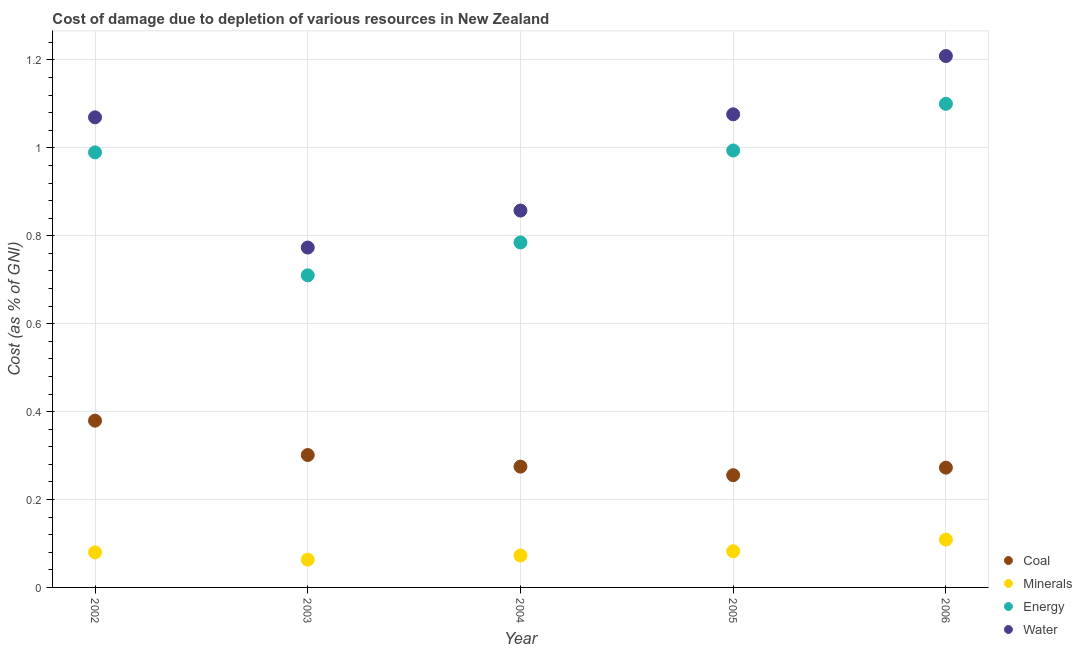How many different coloured dotlines are there?
Offer a very short reply. 4. What is the cost of damage due to depletion of energy in 2002?
Provide a succinct answer. 0.99. Across all years, what is the maximum cost of damage due to depletion of minerals?
Make the answer very short. 0.11. Across all years, what is the minimum cost of damage due to depletion of water?
Your answer should be compact. 0.77. In which year was the cost of damage due to depletion of coal maximum?
Ensure brevity in your answer.  2002. What is the total cost of damage due to depletion of minerals in the graph?
Make the answer very short. 0.41. What is the difference between the cost of damage due to depletion of minerals in 2002 and that in 2006?
Offer a very short reply. -0.03. What is the difference between the cost of damage due to depletion of energy in 2002 and the cost of damage due to depletion of coal in 2004?
Your answer should be very brief. 0.71. What is the average cost of damage due to depletion of coal per year?
Offer a terse response. 0.3. In the year 2003, what is the difference between the cost of damage due to depletion of water and cost of damage due to depletion of minerals?
Provide a short and direct response. 0.71. What is the ratio of the cost of damage due to depletion of water in 2003 to that in 2004?
Provide a succinct answer. 0.9. Is the difference between the cost of damage due to depletion of water in 2003 and 2006 greater than the difference between the cost of damage due to depletion of energy in 2003 and 2006?
Give a very brief answer. No. What is the difference between the highest and the second highest cost of damage due to depletion of coal?
Offer a terse response. 0.08. What is the difference between the highest and the lowest cost of damage due to depletion of energy?
Offer a terse response. 0.39. Is the sum of the cost of damage due to depletion of energy in 2005 and 2006 greater than the maximum cost of damage due to depletion of minerals across all years?
Offer a terse response. Yes. Is it the case that in every year, the sum of the cost of damage due to depletion of coal and cost of damage due to depletion of minerals is greater than the cost of damage due to depletion of energy?
Keep it short and to the point. No. Does the cost of damage due to depletion of water monotonically increase over the years?
Offer a very short reply. No. How many dotlines are there?
Provide a succinct answer. 4. How many years are there in the graph?
Make the answer very short. 5. What is the difference between two consecutive major ticks on the Y-axis?
Your response must be concise. 0.2. Are the values on the major ticks of Y-axis written in scientific E-notation?
Offer a very short reply. No. Does the graph contain any zero values?
Ensure brevity in your answer.  No. Does the graph contain grids?
Provide a short and direct response. Yes. What is the title of the graph?
Ensure brevity in your answer.  Cost of damage due to depletion of various resources in New Zealand . Does "Offering training" appear as one of the legend labels in the graph?
Your answer should be compact. No. What is the label or title of the Y-axis?
Your response must be concise. Cost (as % of GNI). What is the Cost (as % of GNI) of Coal in 2002?
Your answer should be compact. 0.38. What is the Cost (as % of GNI) in Minerals in 2002?
Provide a succinct answer. 0.08. What is the Cost (as % of GNI) of Energy in 2002?
Make the answer very short. 0.99. What is the Cost (as % of GNI) of Water in 2002?
Your answer should be compact. 1.07. What is the Cost (as % of GNI) of Coal in 2003?
Provide a succinct answer. 0.3. What is the Cost (as % of GNI) in Minerals in 2003?
Your answer should be compact. 0.06. What is the Cost (as % of GNI) in Energy in 2003?
Provide a succinct answer. 0.71. What is the Cost (as % of GNI) of Water in 2003?
Your response must be concise. 0.77. What is the Cost (as % of GNI) in Coal in 2004?
Keep it short and to the point. 0.27. What is the Cost (as % of GNI) in Minerals in 2004?
Ensure brevity in your answer.  0.07. What is the Cost (as % of GNI) of Energy in 2004?
Offer a terse response. 0.78. What is the Cost (as % of GNI) in Water in 2004?
Provide a short and direct response. 0.86. What is the Cost (as % of GNI) of Coal in 2005?
Your answer should be very brief. 0.26. What is the Cost (as % of GNI) in Minerals in 2005?
Give a very brief answer. 0.08. What is the Cost (as % of GNI) of Energy in 2005?
Keep it short and to the point. 0.99. What is the Cost (as % of GNI) of Water in 2005?
Provide a short and direct response. 1.08. What is the Cost (as % of GNI) of Coal in 2006?
Make the answer very short. 0.27. What is the Cost (as % of GNI) in Minerals in 2006?
Offer a very short reply. 0.11. What is the Cost (as % of GNI) of Energy in 2006?
Keep it short and to the point. 1.1. What is the Cost (as % of GNI) of Water in 2006?
Offer a terse response. 1.21. Across all years, what is the maximum Cost (as % of GNI) in Coal?
Keep it short and to the point. 0.38. Across all years, what is the maximum Cost (as % of GNI) of Minerals?
Your response must be concise. 0.11. Across all years, what is the maximum Cost (as % of GNI) in Energy?
Offer a terse response. 1.1. Across all years, what is the maximum Cost (as % of GNI) in Water?
Offer a very short reply. 1.21. Across all years, what is the minimum Cost (as % of GNI) in Coal?
Your answer should be very brief. 0.26. Across all years, what is the minimum Cost (as % of GNI) of Minerals?
Provide a succinct answer. 0.06. Across all years, what is the minimum Cost (as % of GNI) in Energy?
Offer a very short reply. 0.71. Across all years, what is the minimum Cost (as % of GNI) in Water?
Your answer should be compact. 0.77. What is the total Cost (as % of GNI) of Coal in the graph?
Give a very brief answer. 1.48. What is the total Cost (as % of GNI) in Minerals in the graph?
Give a very brief answer. 0.41. What is the total Cost (as % of GNI) in Energy in the graph?
Provide a succinct answer. 4.58. What is the total Cost (as % of GNI) of Water in the graph?
Ensure brevity in your answer.  4.99. What is the difference between the Cost (as % of GNI) of Coal in 2002 and that in 2003?
Give a very brief answer. 0.08. What is the difference between the Cost (as % of GNI) in Minerals in 2002 and that in 2003?
Make the answer very short. 0.02. What is the difference between the Cost (as % of GNI) of Energy in 2002 and that in 2003?
Offer a terse response. 0.28. What is the difference between the Cost (as % of GNI) in Water in 2002 and that in 2003?
Your answer should be very brief. 0.3. What is the difference between the Cost (as % of GNI) in Coal in 2002 and that in 2004?
Offer a very short reply. 0.1. What is the difference between the Cost (as % of GNI) of Minerals in 2002 and that in 2004?
Offer a terse response. 0.01. What is the difference between the Cost (as % of GNI) in Energy in 2002 and that in 2004?
Offer a very short reply. 0.2. What is the difference between the Cost (as % of GNI) of Water in 2002 and that in 2004?
Your response must be concise. 0.21. What is the difference between the Cost (as % of GNI) of Coal in 2002 and that in 2005?
Your response must be concise. 0.12. What is the difference between the Cost (as % of GNI) of Minerals in 2002 and that in 2005?
Offer a very short reply. -0. What is the difference between the Cost (as % of GNI) in Energy in 2002 and that in 2005?
Offer a very short reply. -0. What is the difference between the Cost (as % of GNI) of Water in 2002 and that in 2005?
Ensure brevity in your answer.  -0.01. What is the difference between the Cost (as % of GNI) in Coal in 2002 and that in 2006?
Your answer should be very brief. 0.11. What is the difference between the Cost (as % of GNI) in Minerals in 2002 and that in 2006?
Ensure brevity in your answer.  -0.03. What is the difference between the Cost (as % of GNI) of Energy in 2002 and that in 2006?
Give a very brief answer. -0.11. What is the difference between the Cost (as % of GNI) in Water in 2002 and that in 2006?
Keep it short and to the point. -0.14. What is the difference between the Cost (as % of GNI) in Coal in 2003 and that in 2004?
Your answer should be compact. 0.03. What is the difference between the Cost (as % of GNI) in Minerals in 2003 and that in 2004?
Provide a succinct answer. -0.01. What is the difference between the Cost (as % of GNI) of Energy in 2003 and that in 2004?
Your response must be concise. -0.07. What is the difference between the Cost (as % of GNI) of Water in 2003 and that in 2004?
Your answer should be very brief. -0.08. What is the difference between the Cost (as % of GNI) in Coal in 2003 and that in 2005?
Offer a very short reply. 0.05. What is the difference between the Cost (as % of GNI) of Minerals in 2003 and that in 2005?
Your answer should be compact. -0.02. What is the difference between the Cost (as % of GNI) in Energy in 2003 and that in 2005?
Keep it short and to the point. -0.28. What is the difference between the Cost (as % of GNI) in Water in 2003 and that in 2005?
Offer a very short reply. -0.3. What is the difference between the Cost (as % of GNI) of Coal in 2003 and that in 2006?
Your answer should be very brief. 0.03. What is the difference between the Cost (as % of GNI) in Minerals in 2003 and that in 2006?
Ensure brevity in your answer.  -0.05. What is the difference between the Cost (as % of GNI) in Energy in 2003 and that in 2006?
Ensure brevity in your answer.  -0.39. What is the difference between the Cost (as % of GNI) of Water in 2003 and that in 2006?
Provide a short and direct response. -0.44. What is the difference between the Cost (as % of GNI) in Coal in 2004 and that in 2005?
Your response must be concise. 0.02. What is the difference between the Cost (as % of GNI) of Minerals in 2004 and that in 2005?
Offer a very short reply. -0.01. What is the difference between the Cost (as % of GNI) of Energy in 2004 and that in 2005?
Make the answer very short. -0.21. What is the difference between the Cost (as % of GNI) in Water in 2004 and that in 2005?
Your answer should be very brief. -0.22. What is the difference between the Cost (as % of GNI) of Coal in 2004 and that in 2006?
Give a very brief answer. 0. What is the difference between the Cost (as % of GNI) of Minerals in 2004 and that in 2006?
Your response must be concise. -0.04. What is the difference between the Cost (as % of GNI) in Energy in 2004 and that in 2006?
Make the answer very short. -0.32. What is the difference between the Cost (as % of GNI) of Water in 2004 and that in 2006?
Keep it short and to the point. -0.35. What is the difference between the Cost (as % of GNI) of Coal in 2005 and that in 2006?
Keep it short and to the point. -0.02. What is the difference between the Cost (as % of GNI) in Minerals in 2005 and that in 2006?
Provide a succinct answer. -0.03. What is the difference between the Cost (as % of GNI) of Energy in 2005 and that in 2006?
Your answer should be very brief. -0.11. What is the difference between the Cost (as % of GNI) in Water in 2005 and that in 2006?
Make the answer very short. -0.13. What is the difference between the Cost (as % of GNI) of Coal in 2002 and the Cost (as % of GNI) of Minerals in 2003?
Your answer should be very brief. 0.32. What is the difference between the Cost (as % of GNI) of Coal in 2002 and the Cost (as % of GNI) of Energy in 2003?
Ensure brevity in your answer.  -0.33. What is the difference between the Cost (as % of GNI) of Coal in 2002 and the Cost (as % of GNI) of Water in 2003?
Your response must be concise. -0.39. What is the difference between the Cost (as % of GNI) in Minerals in 2002 and the Cost (as % of GNI) in Energy in 2003?
Your response must be concise. -0.63. What is the difference between the Cost (as % of GNI) of Minerals in 2002 and the Cost (as % of GNI) of Water in 2003?
Your answer should be compact. -0.69. What is the difference between the Cost (as % of GNI) in Energy in 2002 and the Cost (as % of GNI) in Water in 2003?
Offer a very short reply. 0.22. What is the difference between the Cost (as % of GNI) in Coal in 2002 and the Cost (as % of GNI) in Minerals in 2004?
Keep it short and to the point. 0.31. What is the difference between the Cost (as % of GNI) in Coal in 2002 and the Cost (as % of GNI) in Energy in 2004?
Ensure brevity in your answer.  -0.41. What is the difference between the Cost (as % of GNI) of Coal in 2002 and the Cost (as % of GNI) of Water in 2004?
Offer a terse response. -0.48. What is the difference between the Cost (as % of GNI) of Minerals in 2002 and the Cost (as % of GNI) of Energy in 2004?
Provide a short and direct response. -0.71. What is the difference between the Cost (as % of GNI) of Minerals in 2002 and the Cost (as % of GNI) of Water in 2004?
Keep it short and to the point. -0.78. What is the difference between the Cost (as % of GNI) of Energy in 2002 and the Cost (as % of GNI) of Water in 2004?
Provide a succinct answer. 0.13. What is the difference between the Cost (as % of GNI) of Coal in 2002 and the Cost (as % of GNI) of Minerals in 2005?
Your response must be concise. 0.3. What is the difference between the Cost (as % of GNI) in Coal in 2002 and the Cost (as % of GNI) in Energy in 2005?
Make the answer very short. -0.61. What is the difference between the Cost (as % of GNI) in Coal in 2002 and the Cost (as % of GNI) in Water in 2005?
Give a very brief answer. -0.7. What is the difference between the Cost (as % of GNI) of Minerals in 2002 and the Cost (as % of GNI) of Energy in 2005?
Keep it short and to the point. -0.91. What is the difference between the Cost (as % of GNI) in Minerals in 2002 and the Cost (as % of GNI) in Water in 2005?
Keep it short and to the point. -1. What is the difference between the Cost (as % of GNI) in Energy in 2002 and the Cost (as % of GNI) in Water in 2005?
Offer a terse response. -0.09. What is the difference between the Cost (as % of GNI) in Coal in 2002 and the Cost (as % of GNI) in Minerals in 2006?
Offer a terse response. 0.27. What is the difference between the Cost (as % of GNI) in Coal in 2002 and the Cost (as % of GNI) in Energy in 2006?
Offer a terse response. -0.72. What is the difference between the Cost (as % of GNI) of Coal in 2002 and the Cost (as % of GNI) of Water in 2006?
Keep it short and to the point. -0.83. What is the difference between the Cost (as % of GNI) of Minerals in 2002 and the Cost (as % of GNI) of Energy in 2006?
Provide a short and direct response. -1.02. What is the difference between the Cost (as % of GNI) in Minerals in 2002 and the Cost (as % of GNI) in Water in 2006?
Keep it short and to the point. -1.13. What is the difference between the Cost (as % of GNI) in Energy in 2002 and the Cost (as % of GNI) in Water in 2006?
Provide a succinct answer. -0.22. What is the difference between the Cost (as % of GNI) of Coal in 2003 and the Cost (as % of GNI) of Minerals in 2004?
Provide a short and direct response. 0.23. What is the difference between the Cost (as % of GNI) of Coal in 2003 and the Cost (as % of GNI) of Energy in 2004?
Offer a very short reply. -0.48. What is the difference between the Cost (as % of GNI) of Coal in 2003 and the Cost (as % of GNI) of Water in 2004?
Your answer should be compact. -0.56. What is the difference between the Cost (as % of GNI) of Minerals in 2003 and the Cost (as % of GNI) of Energy in 2004?
Provide a succinct answer. -0.72. What is the difference between the Cost (as % of GNI) of Minerals in 2003 and the Cost (as % of GNI) of Water in 2004?
Provide a succinct answer. -0.79. What is the difference between the Cost (as % of GNI) in Energy in 2003 and the Cost (as % of GNI) in Water in 2004?
Give a very brief answer. -0.15. What is the difference between the Cost (as % of GNI) of Coal in 2003 and the Cost (as % of GNI) of Minerals in 2005?
Make the answer very short. 0.22. What is the difference between the Cost (as % of GNI) of Coal in 2003 and the Cost (as % of GNI) of Energy in 2005?
Your answer should be compact. -0.69. What is the difference between the Cost (as % of GNI) in Coal in 2003 and the Cost (as % of GNI) in Water in 2005?
Keep it short and to the point. -0.78. What is the difference between the Cost (as % of GNI) of Minerals in 2003 and the Cost (as % of GNI) of Energy in 2005?
Your answer should be very brief. -0.93. What is the difference between the Cost (as % of GNI) in Minerals in 2003 and the Cost (as % of GNI) in Water in 2005?
Offer a terse response. -1.01. What is the difference between the Cost (as % of GNI) in Energy in 2003 and the Cost (as % of GNI) in Water in 2005?
Provide a succinct answer. -0.37. What is the difference between the Cost (as % of GNI) of Coal in 2003 and the Cost (as % of GNI) of Minerals in 2006?
Give a very brief answer. 0.19. What is the difference between the Cost (as % of GNI) in Coal in 2003 and the Cost (as % of GNI) in Energy in 2006?
Your answer should be very brief. -0.8. What is the difference between the Cost (as % of GNI) of Coal in 2003 and the Cost (as % of GNI) of Water in 2006?
Keep it short and to the point. -0.91. What is the difference between the Cost (as % of GNI) of Minerals in 2003 and the Cost (as % of GNI) of Energy in 2006?
Your answer should be compact. -1.04. What is the difference between the Cost (as % of GNI) in Minerals in 2003 and the Cost (as % of GNI) in Water in 2006?
Ensure brevity in your answer.  -1.15. What is the difference between the Cost (as % of GNI) in Energy in 2003 and the Cost (as % of GNI) in Water in 2006?
Give a very brief answer. -0.5. What is the difference between the Cost (as % of GNI) in Coal in 2004 and the Cost (as % of GNI) in Minerals in 2005?
Your answer should be compact. 0.19. What is the difference between the Cost (as % of GNI) of Coal in 2004 and the Cost (as % of GNI) of Energy in 2005?
Give a very brief answer. -0.72. What is the difference between the Cost (as % of GNI) of Coal in 2004 and the Cost (as % of GNI) of Water in 2005?
Offer a very short reply. -0.8. What is the difference between the Cost (as % of GNI) of Minerals in 2004 and the Cost (as % of GNI) of Energy in 2005?
Your response must be concise. -0.92. What is the difference between the Cost (as % of GNI) in Minerals in 2004 and the Cost (as % of GNI) in Water in 2005?
Give a very brief answer. -1. What is the difference between the Cost (as % of GNI) of Energy in 2004 and the Cost (as % of GNI) of Water in 2005?
Ensure brevity in your answer.  -0.29. What is the difference between the Cost (as % of GNI) in Coal in 2004 and the Cost (as % of GNI) in Minerals in 2006?
Keep it short and to the point. 0.17. What is the difference between the Cost (as % of GNI) in Coal in 2004 and the Cost (as % of GNI) in Energy in 2006?
Offer a terse response. -0.83. What is the difference between the Cost (as % of GNI) in Coal in 2004 and the Cost (as % of GNI) in Water in 2006?
Offer a very short reply. -0.93. What is the difference between the Cost (as % of GNI) in Minerals in 2004 and the Cost (as % of GNI) in Energy in 2006?
Make the answer very short. -1.03. What is the difference between the Cost (as % of GNI) of Minerals in 2004 and the Cost (as % of GNI) of Water in 2006?
Provide a short and direct response. -1.14. What is the difference between the Cost (as % of GNI) of Energy in 2004 and the Cost (as % of GNI) of Water in 2006?
Keep it short and to the point. -0.42. What is the difference between the Cost (as % of GNI) in Coal in 2005 and the Cost (as % of GNI) in Minerals in 2006?
Your answer should be very brief. 0.15. What is the difference between the Cost (as % of GNI) in Coal in 2005 and the Cost (as % of GNI) in Energy in 2006?
Give a very brief answer. -0.84. What is the difference between the Cost (as % of GNI) in Coal in 2005 and the Cost (as % of GNI) in Water in 2006?
Your response must be concise. -0.95. What is the difference between the Cost (as % of GNI) of Minerals in 2005 and the Cost (as % of GNI) of Energy in 2006?
Provide a succinct answer. -1.02. What is the difference between the Cost (as % of GNI) of Minerals in 2005 and the Cost (as % of GNI) of Water in 2006?
Offer a very short reply. -1.13. What is the difference between the Cost (as % of GNI) in Energy in 2005 and the Cost (as % of GNI) in Water in 2006?
Provide a succinct answer. -0.21. What is the average Cost (as % of GNI) in Coal per year?
Provide a succinct answer. 0.3. What is the average Cost (as % of GNI) in Minerals per year?
Ensure brevity in your answer.  0.08. What is the average Cost (as % of GNI) of Energy per year?
Offer a terse response. 0.92. What is the average Cost (as % of GNI) of Water per year?
Your answer should be very brief. 1. In the year 2002, what is the difference between the Cost (as % of GNI) in Coal and Cost (as % of GNI) in Minerals?
Provide a succinct answer. 0.3. In the year 2002, what is the difference between the Cost (as % of GNI) of Coal and Cost (as % of GNI) of Energy?
Keep it short and to the point. -0.61. In the year 2002, what is the difference between the Cost (as % of GNI) in Coal and Cost (as % of GNI) in Water?
Ensure brevity in your answer.  -0.69. In the year 2002, what is the difference between the Cost (as % of GNI) in Minerals and Cost (as % of GNI) in Energy?
Your answer should be compact. -0.91. In the year 2002, what is the difference between the Cost (as % of GNI) of Minerals and Cost (as % of GNI) of Water?
Your answer should be compact. -0.99. In the year 2002, what is the difference between the Cost (as % of GNI) of Energy and Cost (as % of GNI) of Water?
Provide a short and direct response. -0.08. In the year 2003, what is the difference between the Cost (as % of GNI) in Coal and Cost (as % of GNI) in Minerals?
Give a very brief answer. 0.24. In the year 2003, what is the difference between the Cost (as % of GNI) of Coal and Cost (as % of GNI) of Energy?
Your answer should be very brief. -0.41. In the year 2003, what is the difference between the Cost (as % of GNI) in Coal and Cost (as % of GNI) in Water?
Make the answer very short. -0.47. In the year 2003, what is the difference between the Cost (as % of GNI) in Minerals and Cost (as % of GNI) in Energy?
Offer a very short reply. -0.65. In the year 2003, what is the difference between the Cost (as % of GNI) of Minerals and Cost (as % of GNI) of Water?
Make the answer very short. -0.71. In the year 2003, what is the difference between the Cost (as % of GNI) of Energy and Cost (as % of GNI) of Water?
Offer a very short reply. -0.06. In the year 2004, what is the difference between the Cost (as % of GNI) in Coal and Cost (as % of GNI) in Minerals?
Your response must be concise. 0.2. In the year 2004, what is the difference between the Cost (as % of GNI) in Coal and Cost (as % of GNI) in Energy?
Your answer should be very brief. -0.51. In the year 2004, what is the difference between the Cost (as % of GNI) in Coal and Cost (as % of GNI) in Water?
Provide a succinct answer. -0.58. In the year 2004, what is the difference between the Cost (as % of GNI) of Minerals and Cost (as % of GNI) of Energy?
Provide a succinct answer. -0.71. In the year 2004, what is the difference between the Cost (as % of GNI) of Minerals and Cost (as % of GNI) of Water?
Provide a succinct answer. -0.78. In the year 2004, what is the difference between the Cost (as % of GNI) of Energy and Cost (as % of GNI) of Water?
Make the answer very short. -0.07. In the year 2005, what is the difference between the Cost (as % of GNI) in Coal and Cost (as % of GNI) in Minerals?
Ensure brevity in your answer.  0.17. In the year 2005, what is the difference between the Cost (as % of GNI) of Coal and Cost (as % of GNI) of Energy?
Keep it short and to the point. -0.74. In the year 2005, what is the difference between the Cost (as % of GNI) in Coal and Cost (as % of GNI) in Water?
Your answer should be compact. -0.82. In the year 2005, what is the difference between the Cost (as % of GNI) of Minerals and Cost (as % of GNI) of Energy?
Your answer should be very brief. -0.91. In the year 2005, what is the difference between the Cost (as % of GNI) in Minerals and Cost (as % of GNI) in Water?
Offer a terse response. -0.99. In the year 2005, what is the difference between the Cost (as % of GNI) in Energy and Cost (as % of GNI) in Water?
Offer a terse response. -0.08. In the year 2006, what is the difference between the Cost (as % of GNI) of Coal and Cost (as % of GNI) of Minerals?
Provide a succinct answer. 0.16. In the year 2006, what is the difference between the Cost (as % of GNI) of Coal and Cost (as % of GNI) of Energy?
Your answer should be very brief. -0.83. In the year 2006, what is the difference between the Cost (as % of GNI) of Coal and Cost (as % of GNI) of Water?
Your answer should be very brief. -0.94. In the year 2006, what is the difference between the Cost (as % of GNI) in Minerals and Cost (as % of GNI) in Energy?
Provide a short and direct response. -0.99. In the year 2006, what is the difference between the Cost (as % of GNI) in Minerals and Cost (as % of GNI) in Water?
Your answer should be compact. -1.1. In the year 2006, what is the difference between the Cost (as % of GNI) of Energy and Cost (as % of GNI) of Water?
Offer a terse response. -0.11. What is the ratio of the Cost (as % of GNI) of Coal in 2002 to that in 2003?
Your answer should be very brief. 1.26. What is the ratio of the Cost (as % of GNI) of Minerals in 2002 to that in 2003?
Your answer should be very brief. 1.26. What is the ratio of the Cost (as % of GNI) of Energy in 2002 to that in 2003?
Provide a short and direct response. 1.39. What is the ratio of the Cost (as % of GNI) of Water in 2002 to that in 2003?
Give a very brief answer. 1.38. What is the ratio of the Cost (as % of GNI) of Coal in 2002 to that in 2004?
Keep it short and to the point. 1.38. What is the ratio of the Cost (as % of GNI) in Minerals in 2002 to that in 2004?
Provide a succinct answer. 1.1. What is the ratio of the Cost (as % of GNI) in Energy in 2002 to that in 2004?
Give a very brief answer. 1.26. What is the ratio of the Cost (as % of GNI) in Water in 2002 to that in 2004?
Keep it short and to the point. 1.25. What is the ratio of the Cost (as % of GNI) in Coal in 2002 to that in 2005?
Offer a terse response. 1.49. What is the ratio of the Cost (as % of GNI) of Minerals in 2002 to that in 2005?
Give a very brief answer. 0.97. What is the ratio of the Cost (as % of GNI) of Energy in 2002 to that in 2005?
Your response must be concise. 1. What is the ratio of the Cost (as % of GNI) of Coal in 2002 to that in 2006?
Keep it short and to the point. 1.39. What is the ratio of the Cost (as % of GNI) in Minerals in 2002 to that in 2006?
Your answer should be compact. 0.73. What is the ratio of the Cost (as % of GNI) of Energy in 2002 to that in 2006?
Your answer should be compact. 0.9. What is the ratio of the Cost (as % of GNI) in Water in 2002 to that in 2006?
Offer a terse response. 0.88. What is the ratio of the Cost (as % of GNI) of Coal in 2003 to that in 2004?
Make the answer very short. 1.1. What is the ratio of the Cost (as % of GNI) in Minerals in 2003 to that in 2004?
Offer a very short reply. 0.87. What is the ratio of the Cost (as % of GNI) of Energy in 2003 to that in 2004?
Ensure brevity in your answer.  0.9. What is the ratio of the Cost (as % of GNI) in Water in 2003 to that in 2004?
Ensure brevity in your answer.  0.9. What is the ratio of the Cost (as % of GNI) in Coal in 2003 to that in 2005?
Your answer should be compact. 1.18. What is the ratio of the Cost (as % of GNI) in Minerals in 2003 to that in 2005?
Make the answer very short. 0.77. What is the ratio of the Cost (as % of GNI) of Water in 2003 to that in 2005?
Make the answer very short. 0.72. What is the ratio of the Cost (as % of GNI) in Coal in 2003 to that in 2006?
Keep it short and to the point. 1.11. What is the ratio of the Cost (as % of GNI) of Minerals in 2003 to that in 2006?
Offer a terse response. 0.58. What is the ratio of the Cost (as % of GNI) in Energy in 2003 to that in 2006?
Your answer should be compact. 0.65. What is the ratio of the Cost (as % of GNI) of Water in 2003 to that in 2006?
Provide a succinct answer. 0.64. What is the ratio of the Cost (as % of GNI) of Coal in 2004 to that in 2005?
Offer a very short reply. 1.08. What is the ratio of the Cost (as % of GNI) in Minerals in 2004 to that in 2005?
Ensure brevity in your answer.  0.88. What is the ratio of the Cost (as % of GNI) in Energy in 2004 to that in 2005?
Offer a terse response. 0.79. What is the ratio of the Cost (as % of GNI) of Water in 2004 to that in 2005?
Your response must be concise. 0.8. What is the ratio of the Cost (as % of GNI) of Coal in 2004 to that in 2006?
Offer a very short reply. 1.01. What is the ratio of the Cost (as % of GNI) of Minerals in 2004 to that in 2006?
Provide a short and direct response. 0.67. What is the ratio of the Cost (as % of GNI) of Energy in 2004 to that in 2006?
Your response must be concise. 0.71. What is the ratio of the Cost (as % of GNI) in Water in 2004 to that in 2006?
Keep it short and to the point. 0.71. What is the ratio of the Cost (as % of GNI) of Coal in 2005 to that in 2006?
Make the answer very short. 0.94. What is the ratio of the Cost (as % of GNI) of Minerals in 2005 to that in 2006?
Your answer should be very brief. 0.76. What is the ratio of the Cost (as % of GNI) in Energy in 2005 to that in 2006?
Give a very brief answer. 0.9. What is the ratio of the Cost (as % of GNI) of Water in 2005 to that in 2006?
Your response must be concise. 0.89. What is the difference between the highest and the second highest Cost (as % of GNI) of Coal?
Keep it short and to the point. 0.08. What is the difference between the highest and the second highest Cost (as % of GNI) of Minerals?
Offer a terse response. 0.03. What is the difference between the highest and the second highest Cost (as % of GNI) of Energy?
Provide a short and direct response. 0.11. What is the difference between the highest and the second highest Cost (as % of GNI) of Water?
Provide a succinct answer. 0.13. What is the difference between the highest and the lowest Cost (as % of GNI) of Coal?
Ensure brevity in your answer.  0.12. What is the difference between the highest and the lowest Cost (as % of GNI) in Minerals?
Provide a short and direct response. 0.05. What is the difference between the highest and the lowest Cost (as % of GNI) of Energy?
Provide a succinct answer. 0.39. What is the difference between the highest and the lowest Cost (as % of GNI) in Water?
Provide a short and direct response. 0.44. 